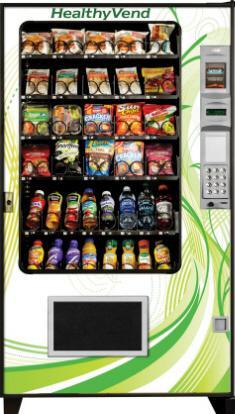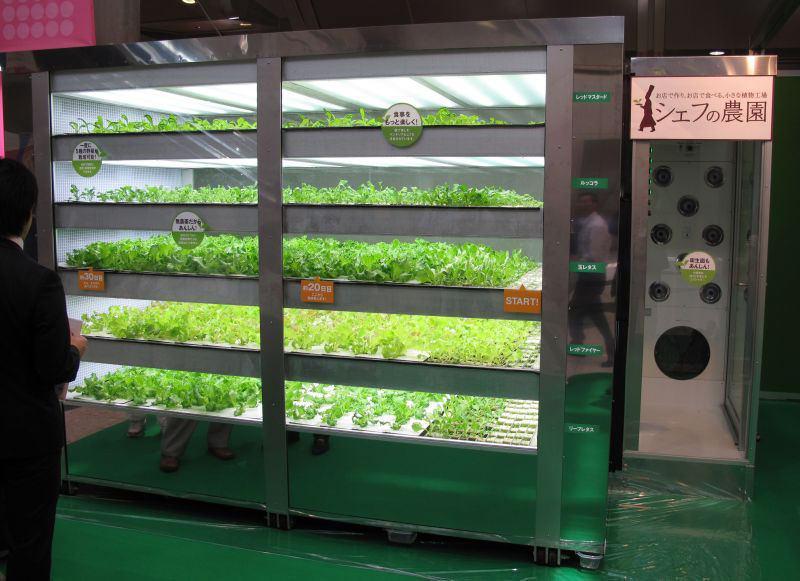The first image is the image on the left, the second image is the image on the right. Considering the images on both sides, is "In one of the images, at least three vending machines are lined up together." valid? Answer yes or no. No. The first image is the image on the left, the second image is the image on the right. Examine the images to the left and right. Is the description "Three or more vending machines sell fresh food." accurate? Answer yes or no. No. 